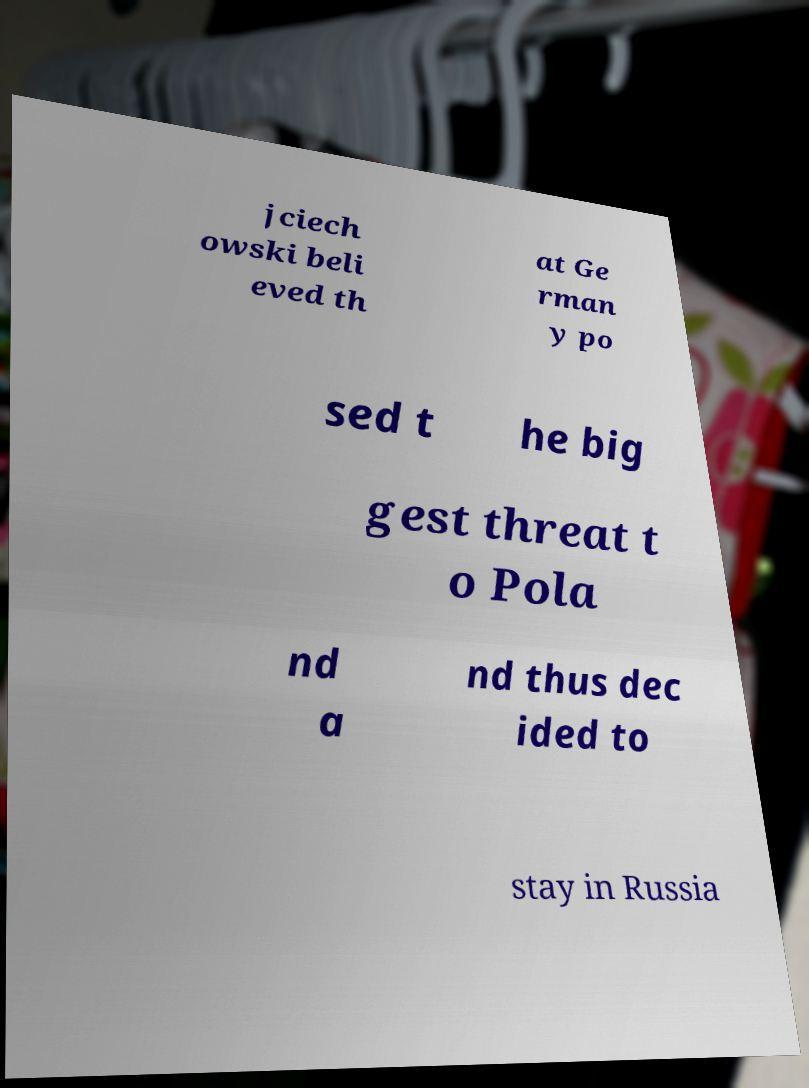Can you accurately transcribe the text from the provided image for me? jciech owski beli eved th at Ge rman y po sed t he big gest threat t o Pola nd a nd thus dec ided to stay in Russia 